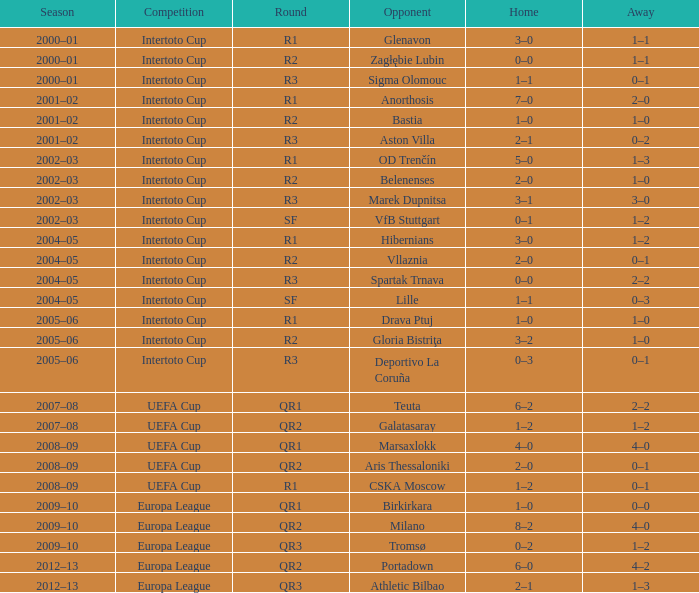What is the home score when playing against marek dupnitsa? 3–1. 